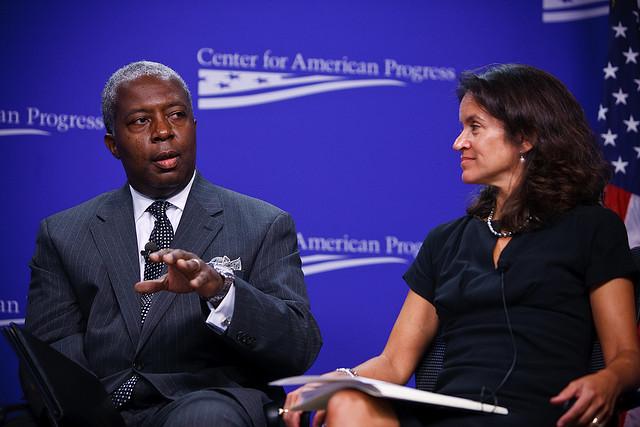Who is sponsoring this discussion?
Be succinct. Center for american progress. What zone does this black man appear to be speaking about?
Answer briefly. Politics. What flag is in the background?
Write a very short answer. American. What color is the man's suit?
Short answer required. Gray. 